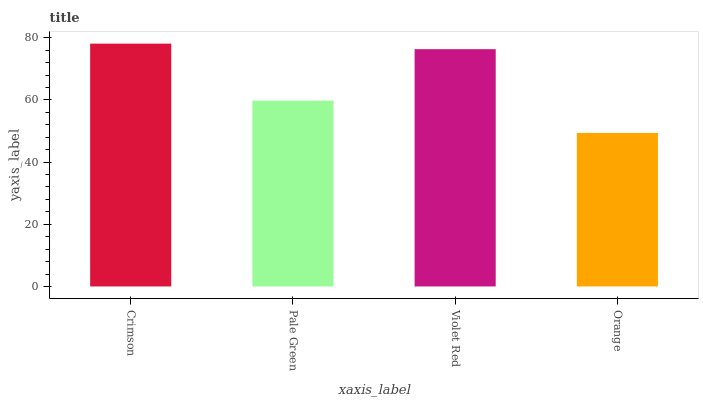Is Orange the minimum?
Answer yes or no. Yes. Is Crimson the maximum?
Answer yes or no. Yes. Is Pale Green the minimum?
Answer yes or no. No. Is Pale Green the maximum?
Answer yes or no. No. Is Crimson greater than Pale Green?
Answer yes or no. Yes. Is Pale Green less than Crimson?
Answer yes or no. Yes. Is Pale Green greater than Crimson?
Answer yes or no. No. Is Crimson less than Pale Green?
Answer yes or no. No. Is Violet Red the high median?
Answer yes or no. Yes. Is Pale Green the low median?
Answer yes or no. Yes. Is Crimson the high median?
Answer yes or no. No. Is Violet Red the low median?
Answer yes or no. No. 